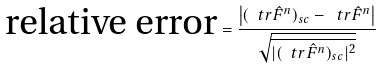<formula> <loc_0><loc_0><loc_500><loc_500>\text {relative error} = \frac { \left | ( \ t r \hat { F } ^ { n } ) _ { s c } - \ t r \hat { F } ^ { n } \right | } { \sqrt { \overline { | ( \ t r \hat { F } ^ { n } ) _ { s c } | ^ { 2 } } } }</formula> 